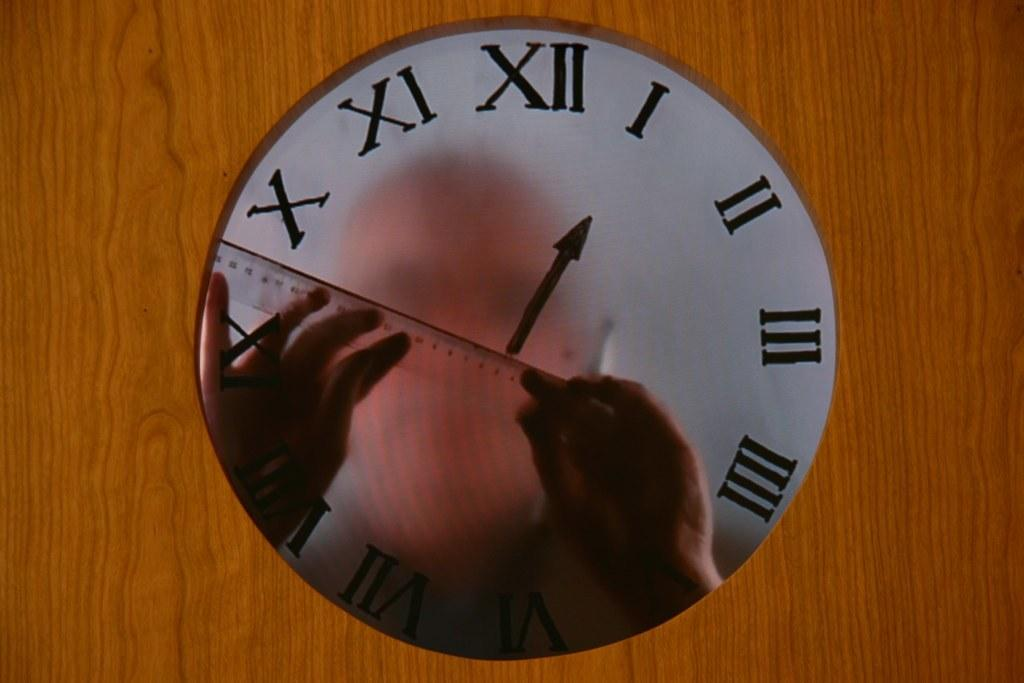<image>
Present a compact description of the photo's key features. Face of a clock that has the hand showing roman numberal 1. 